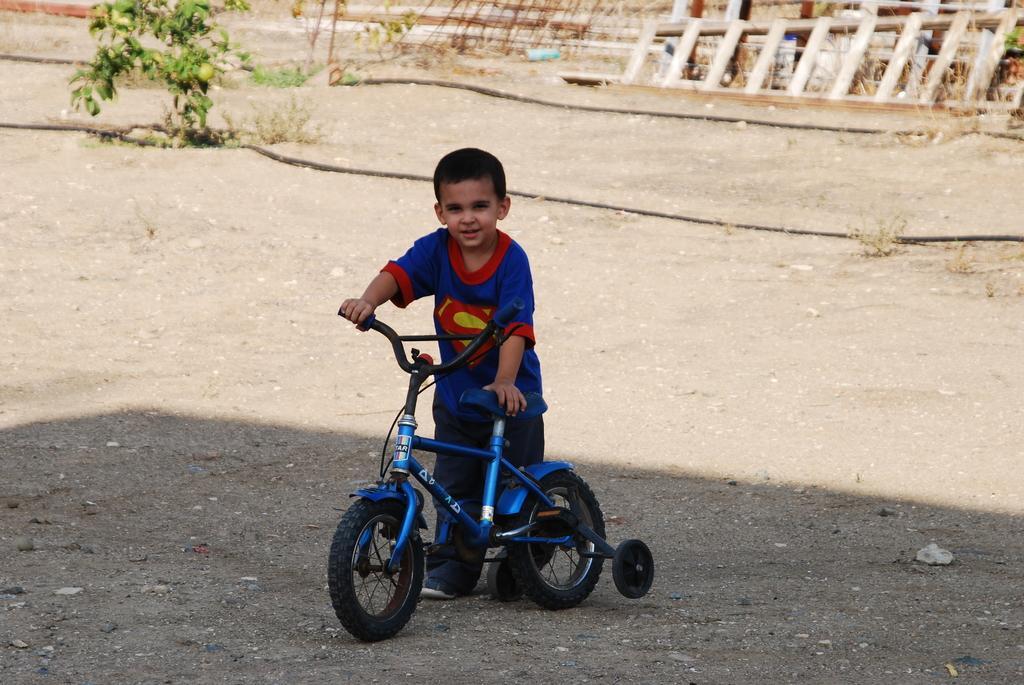In one or two sentences, can you explain what this image depicts? In this image we can see a boy holding a bicycle in his hand. In the background we can see a wooden ladder and a small plant. 